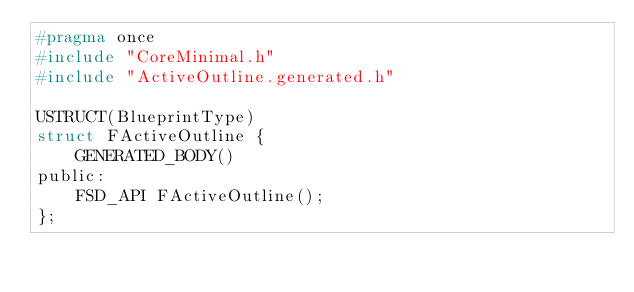<code> <loc_0><loc_0><loc_500><loc_500><_C_>#pragma once
#include "CoreMinimal.h"
#include "ActiveOutline.generated.h"

USTRUCT(BlueprintType)
struct FActiveOutline {
    GENERATED_BODY()
public:
    FSD_API FActiveOutline();
};

</code> 